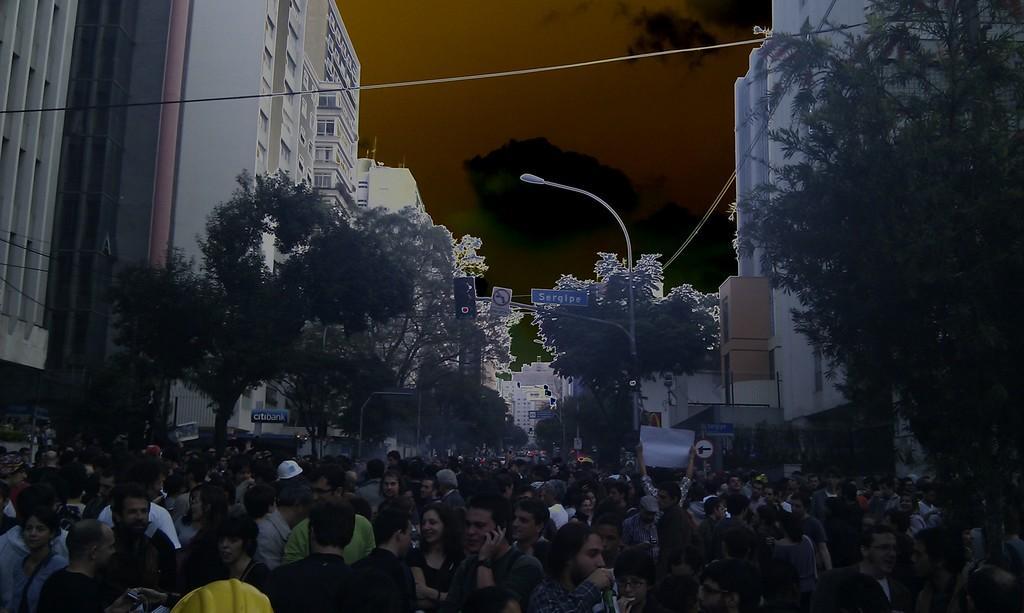Please provide a concise description of this image. In this image I can see at the bottom a group of people are there, in the middle there are trees. There are buildings on either side at the top it is the sky and it is an edited image. 